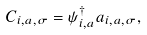<formula> <loc_0><loc_0><loc_500><loc_500>C _ { i , a , \sigma } = \psi ^ { \dagger } _ { i , a } a _ { i , a , \sigma } ,</formula> 